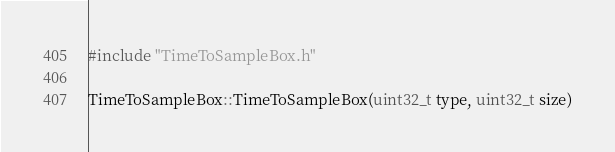<code> <loc_0><loc_0><loc_500><loc_500><_C++_>#include "TimeToSampleBox.h"

TimeToSampleBox::TimeToSampleBox(uint32_t type, uint32_t size)</code> 